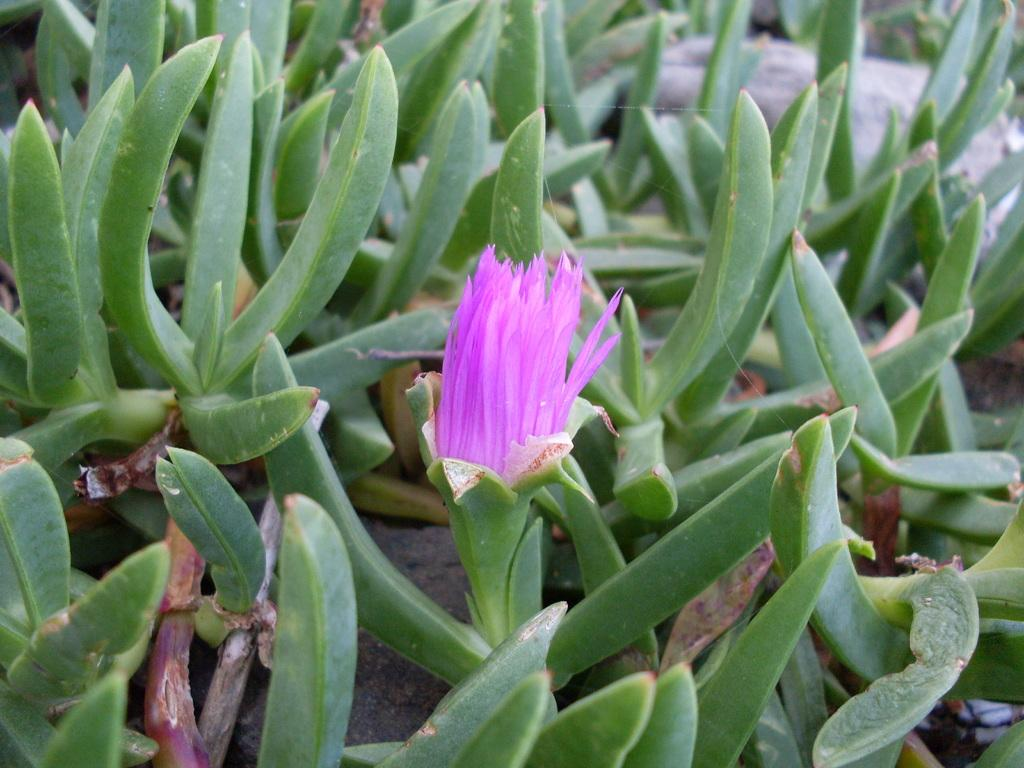What celestial bodies are depicted in the image? There are planets in the image. What type of plant is visible in the image? There is a flower in the image. How many pizzas are being covered by the sister in the image? There are no pizzas or sisters present in the image; it features planets and a flower. 